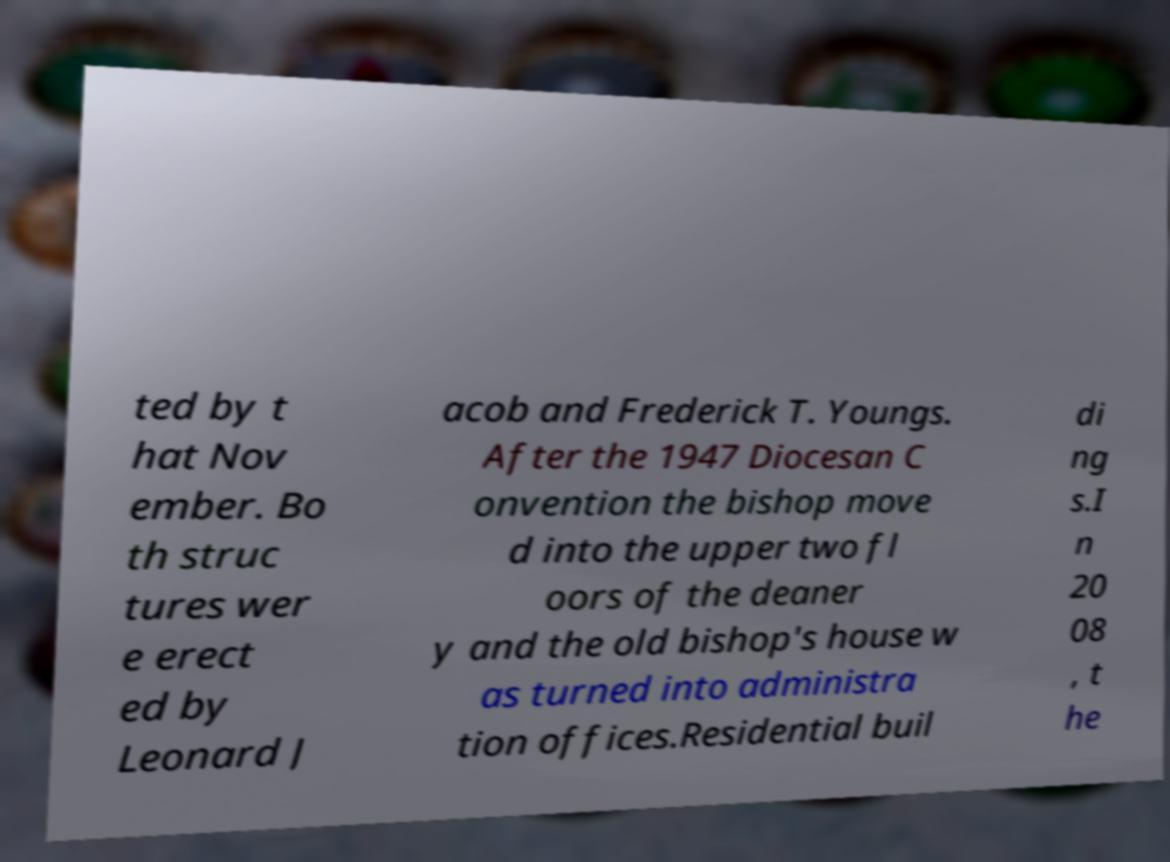Please identify and transcribe the text found in this image. ted by t hat Nov ember. Bo th struc tures wer e erect ed by Leonard J acob and Frederick T. Youngs. After the 1947 Diocesan C onvention the bishop move d into the upper two fl oors of the deaner y and the old bishop's house w as turned into administra tion offices.Residential buil di ng s.I n 20 08 , t he 